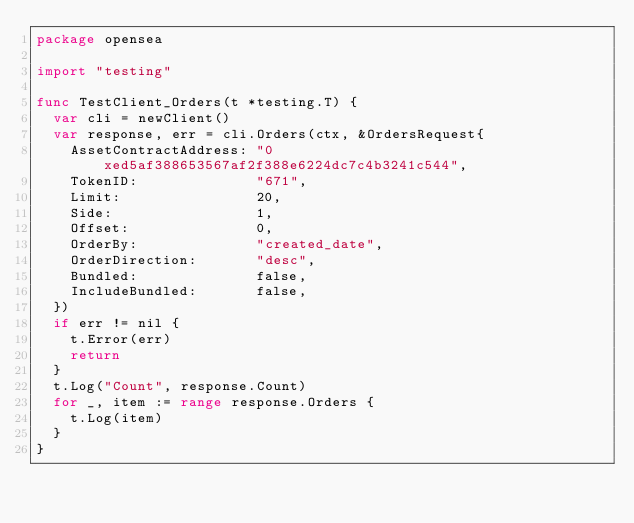<code> <loc_0><loc_0><loc_500><loc_500><_Go_>package opensea

import "testing"

func TestClient_Orders(t *testing.T) {
	var cli = newClient()
	var response, err = cli.Orders(ctx, &OrdersRequest{
		AssetContractAddress: "0xed5af388653567af2f388e6224dc7c4b3241c544",
		TokenID:              "671",
		Limit:                20,
		Side:                 1,
		Offset:               0,
		OrderBy:              "created_date",
		OrderDirection:       "desc",
		Bundled:              false,
		IncludeBundled:       false,
	})
	if err != nil {
		t.Error(err)
		return
	}
	t.Log("Count", response.Count)
	for _, item := range response.Orders {
		t.Log(item)
	}
}
</code> 